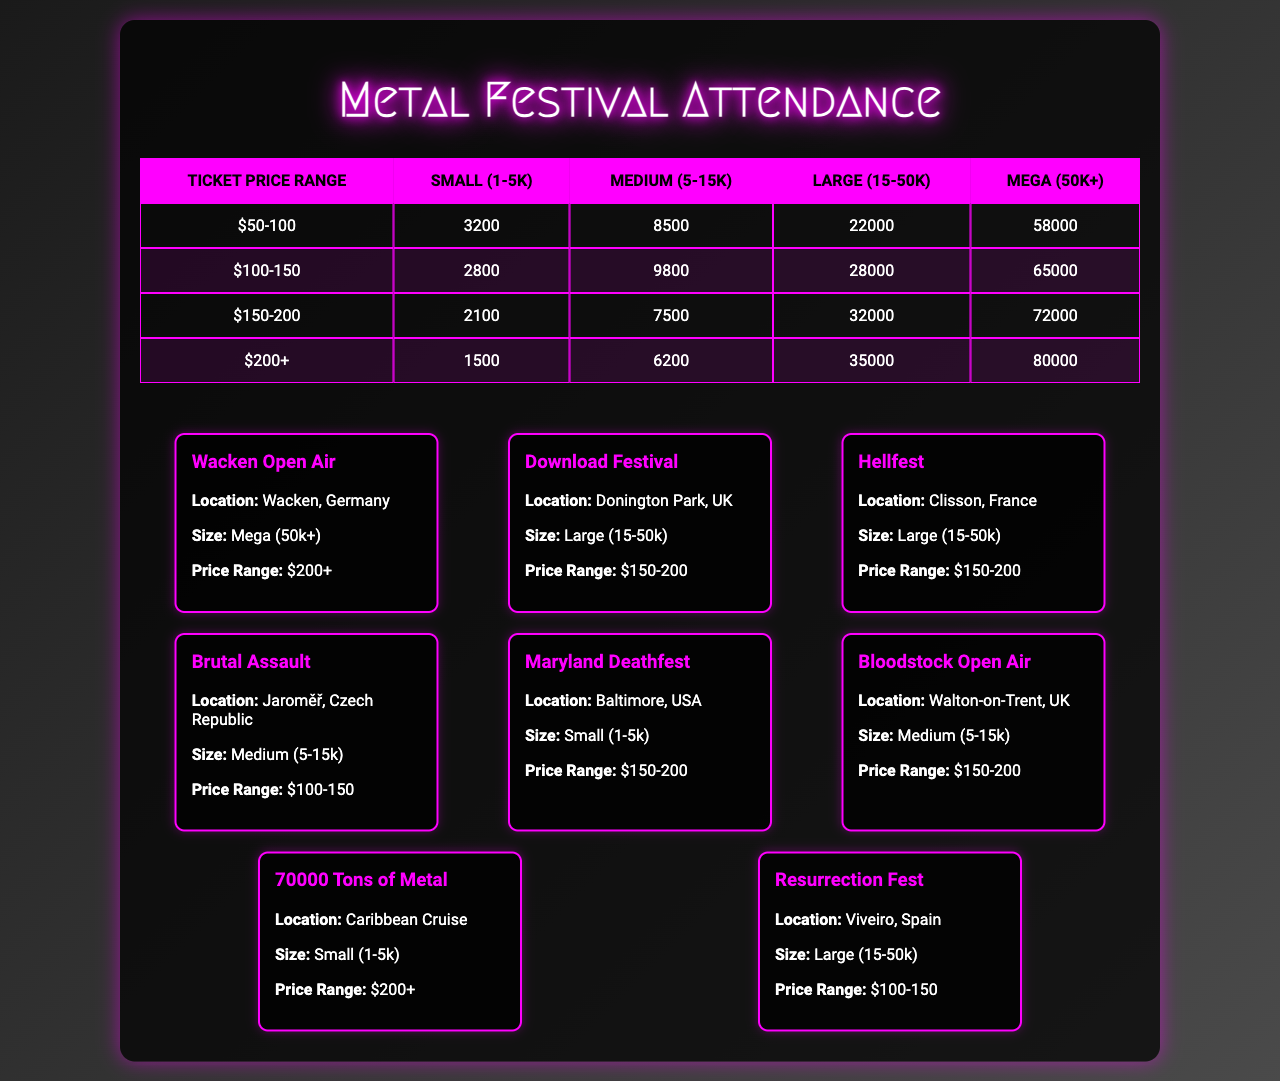What is the highest attendance figure for a Mega venue? The table shows that for the ticket price range of "$200+", the attendance figure for a Mega venue is 80,000.
Answer: 80,000 Which size of venue has the lowest attendance for the ticket price range of $150-200? In the table for the price range of $150-200, the Small (1-5k) venue has the lowest attendance at 2,100.
Answer: 2,100 What is the total attendance for Medium venues across all price ranges? The total for Medium venues is calculated by summing the attendance figures: 8,500 + 9,800 + 7,500 + 6,200 = 31,000.
Answer: 31,000 Is there a Medium venue for the price range of $50-100? Referring to the table, there is no attendance figure listed for Medium venues in the price range of $50-100.
Answer: No For Large venues, what is the difference in attendance between the price ranges of $100-150 and $150-200? For Large venues: $100-150 has 22,000 attendees and $150-200 has 28,000 attendees. The difference is 28,000 - 22,000 = 6,000.
Answer: 6,000 Which ticket price range has the highest average attendance for Small venues? The attendance figures for Small venues in all price ranges are 3,200, 2,800, 2,100, and 1,500. The average is (3,200 + 2,800 + 2,100 + 1,500) / 4 = 2,650.
Answer: 2,650 What is the total attendance for Large venues? The total attendance for Large venues is the sum of the figures: 22,000 (for $50-100) + 28,000 (for $150-200) + 32,000 (for $150-200) + 35,000 (for $200+) = 117,000.
Answer: 117,000 Is the attendance for Small venues in the ticket price range of $200+ lower than for Medium venues in the same range? The Small venue attendance in the $200+ range is 1,500, while the Medium venue has 6,200 attendees, which is higher.
Answer: Yes Which size venue has the largest attendance overall? By observing the largest attendance figures across all price ranges, the Mega venue totals the largest attendance of 80,000.
Answer: Mega (50k+) 